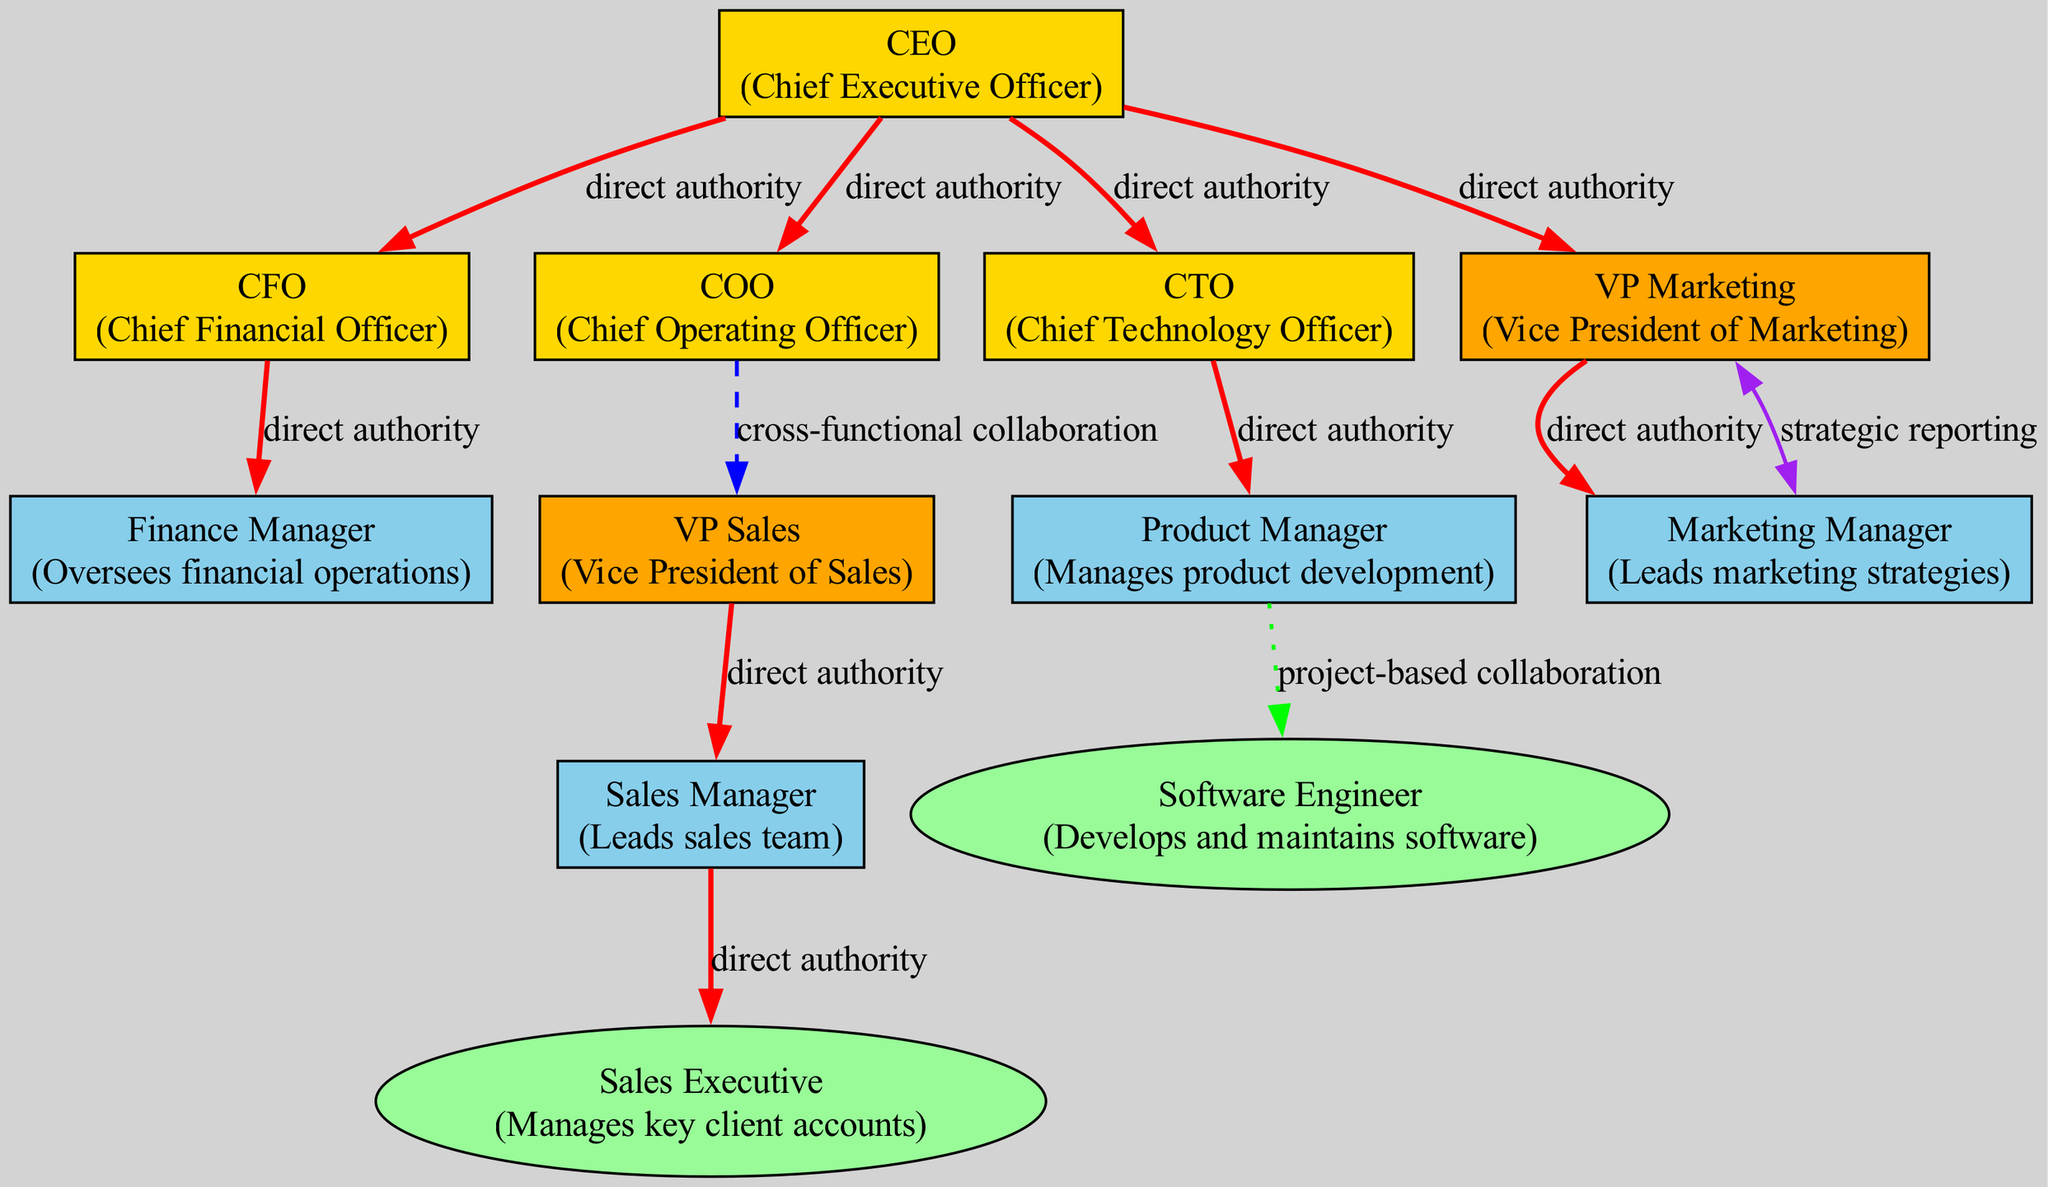What is the total number of nodes in the diagram? The diagram contains a list of nodes, which are the different positions within the corporate hierarchy. By counting each entry in the nodes array, we find that there are a total of 12 nodes.
Answer: 12 Who has direct authority over the VP Marketing? The edges indicate relationships, and one edge points from the CEO to the VP Marketing with the label "direct authority," confirming this relationship.
Answer: CEO What type of relationship exists between COO and VP Sales? The relationship between COO and VP Sales is indicated as "cross-functional collaboration" as per the edge connecting these two nodes.
Answer: cross-functional collaboration How many edges are present in the diagram? The edges represent relationships among the nodes. By counting the entries in the edges array, we determine there are a total of 11 edges in the diagram.
Answer: 11 Which node has the position of managing key client accounts? The description of one of the nodes specifies the position of "Sales Executive," which is responsible for managing key client accounts.
Answer: Sales Executive What is the relationship type between VP Sales and Sales Manager? There is a direct edge from VP Sales to Sales Manager labeled "direct authority," indicating the nature of this relationship.
Answer: direct authority Which position(s) report to the CFO? The CFO has one direct report, specifically the Finance Manager, as indicated by the edge from CFO to Finance Manager with "direct authority."
Answer: Finance Manager How many nodes are categorized as upper management? By identifying the nodes categorized under "upper_management," we find there are 3 such nodes in the diagram: VP Marketing, VP Sales, and CFO.
Answer: 3 Who does the Product Manager collaborate with on a project basis? The edge between Product Manager and Software Engineer indicates "project-based collaboration," illustrating that the Product Manager collaborates with the Software Engineer for projects.
Answer: Software Engineer What authority relationship exists between the CEO and CTO? The edge connecting the CEO and CTO is labeled "direct authority," indicating that the CEO has direct control over the CTO.
Answer: direct authority 